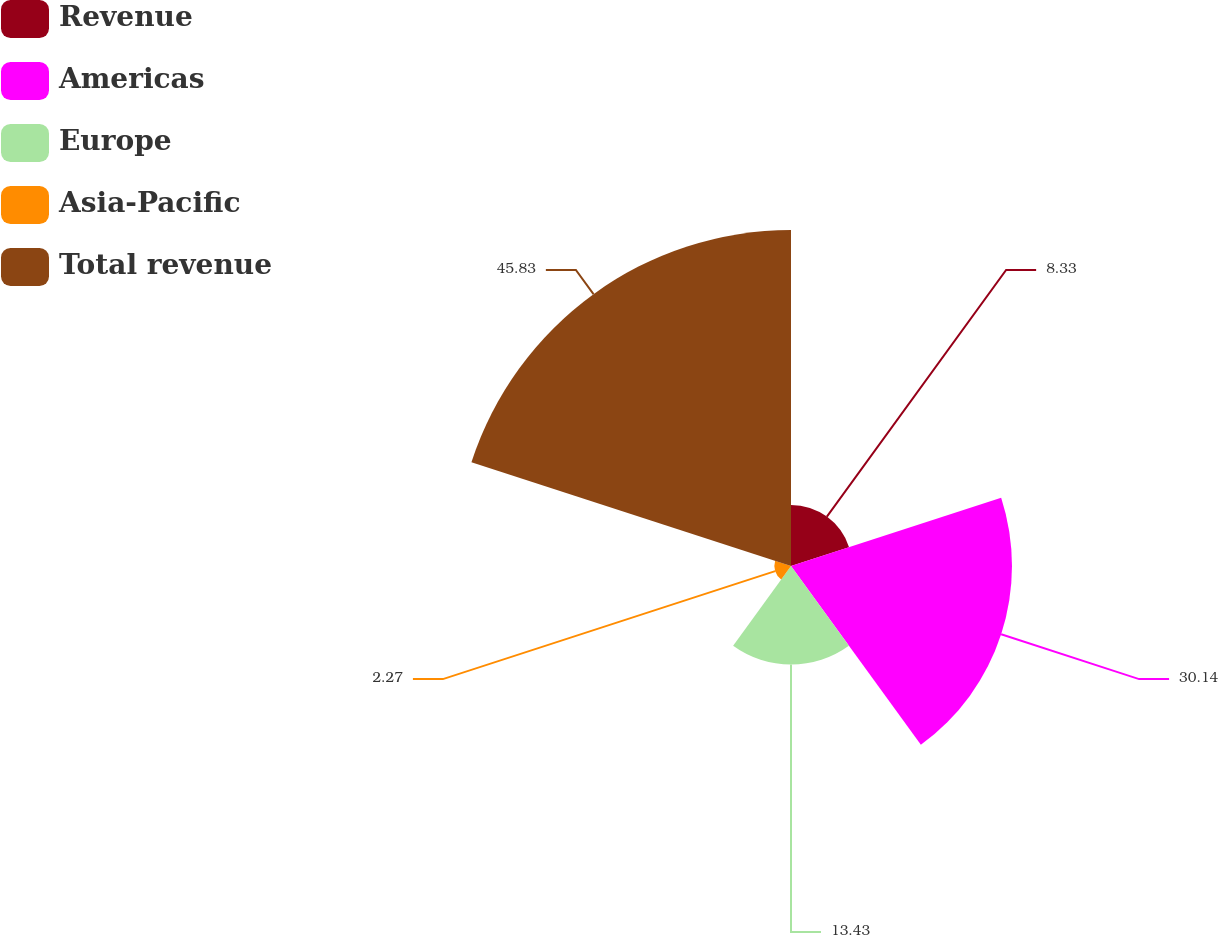Convert chart. <chart><loc_0><loc_0><loc_500><loc_500><pie_chart><fcel>Revenue<fcel>Americas<fcel>Europe<fcel>Asia-Pacific<fcel>Total revenue<nl><fcel>8.33%<fcel>30.14%<fcel>13.43%<fcel>2.27%<fcel>45.83%<nl></chart> 